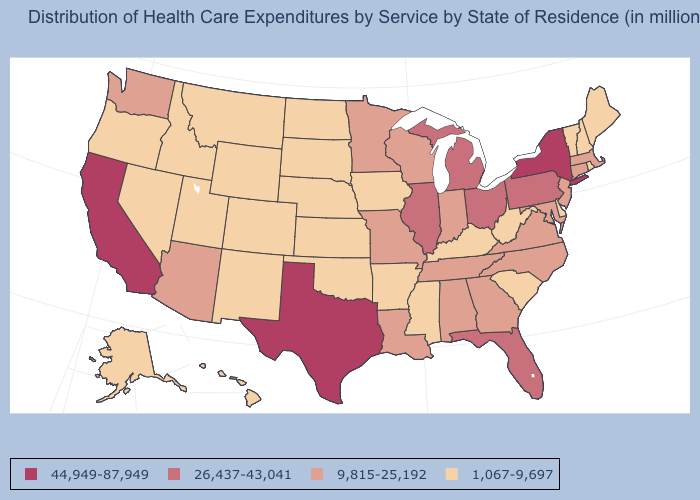Is the legend a continuous bar?
Write a very short answer. No. What is the value of New York?
Concise answer only. 44,949-87,949. What is the value of Montana?
Write a very short answer. 1,067-9,697. What is the value of Colorado?
Quick response, please. 1,067-9,697. Does Wisconsin have the lowest value in the USA?
Answer briefly. No. What is the highest value in the Northeast ?
Quick response, please. 44,949-87,949. What is the highest value in states that border California?
Keep it brief. 9,815-25,192. Does North Dakota have the highest value in the MidWest?
Short answer required. No. What is the highest value in the USA?
Keep it brief. 44,949-87,949. What is the value of Georgia?
Short answer required. 9,815-25,192. What is the value of Utah?
Quick response, please. 1,067-9,697. What is the lowest value in states that border New York?
Answer briefly. 1,067-9,697. What is the value of Colorado?
Concise answer only. 1,067-9,697. What is the highest value in the Northeast ?
Short answer required. 44,949-87,949. Does Georgia have the highest value in the USA?
Answer briefly. No. 